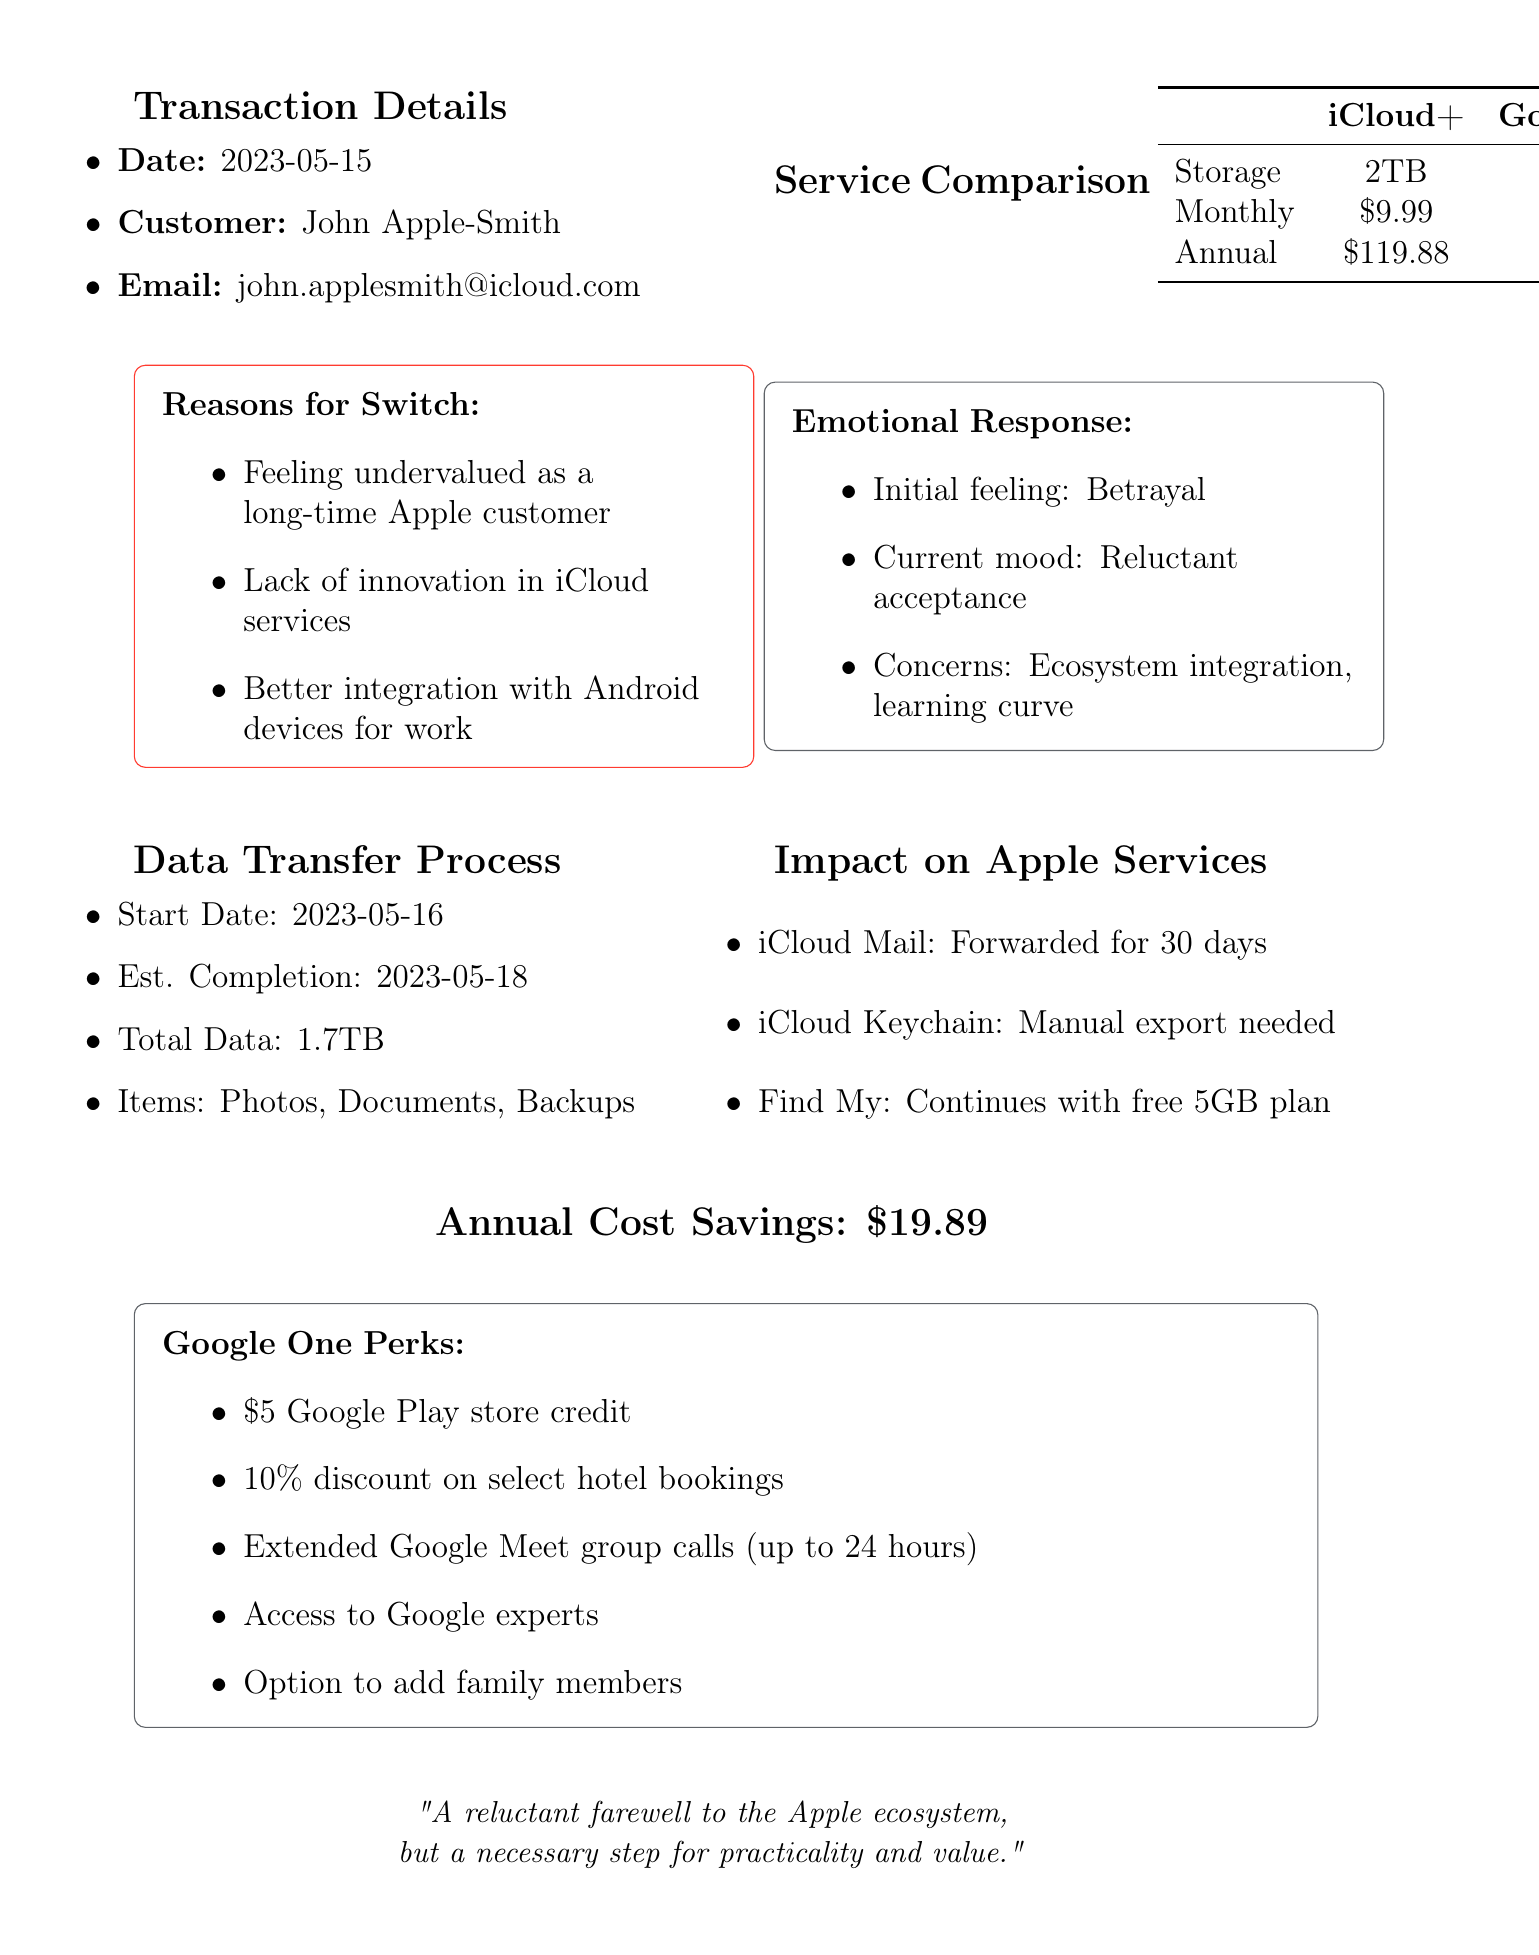What is the transaction date? The transaction date is listed in the document as the date when the switch occurred, which is 2023-05-15.
Answer: 2023-05-15 What is the annual cost of the new Google One plan? The annual cost is mentioned in the service comparison section showing the cost for Google One as $99.99.
Answer: $99.99 How much is the cost savings annually by switching? The annual cost savings is provided in a separate section, showing a savings of $19.89 from the previous plan.
Answer: $19.89 What is the emotional response of the customer initially? The initial emotional response of the customer is indicated as betrayal in the document.
Answer: Betrayal What are two additional features of Google One mentioned? The document lists several features and two of them include access to Google experts and the option to add family members.
Answer: Access to Google experts, Option to add family members What total data size is being transferred? The total data size is specified in the data transfer process section as 1.7TB.
Answer: 1.7TB What will happen to iCloud Mail after switching? The document states that iCloud Mail will be forwarded to Gmail for 30 days after the switch.
Answer: Will be forwarded to Gmail for 30 days What plan did the customer switch from? The previous service plan is stated as the 2TB Storage Plan from Apple iCloud+.
Answer: 2TB Storage Plan What is the total number of items to transfer? The items listed for transfer include photos, documents, and backups, indicating a total of three items.
Answer: 3 items 